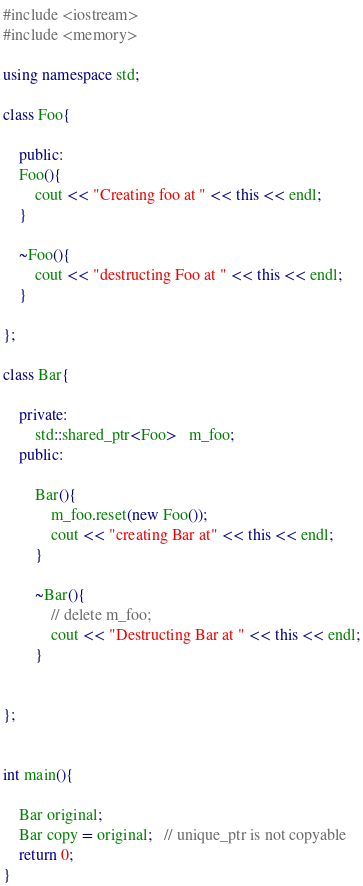<code> <loc_0><loc_0><loc_500><loc_500><_C++_>
#include <iostream>
#include <memory>

using namespace std;

class Foo{

    public:
    Foo(){
        cout << "Creating foo at " << this << endl;
    }

    ~Foo(){
        cout << "destructing Foo at " << this << endl;
    }

};

class Bar{

    private:
        std::shared_ptr<Foo>   m_foo;
    public:

        Bar(){
            m_foo.reset(new Foo());
            cout << "creating Bar at" << this << endl;
        }

        ~Bar(){
            // delete m_foo;
            cout << "Destructing Bar at " << this << endl;
        }


};


int main(){

    Bar original;
    Bar copy = original;   // unique_ptr is not copyable
    return 0;
}</code> 